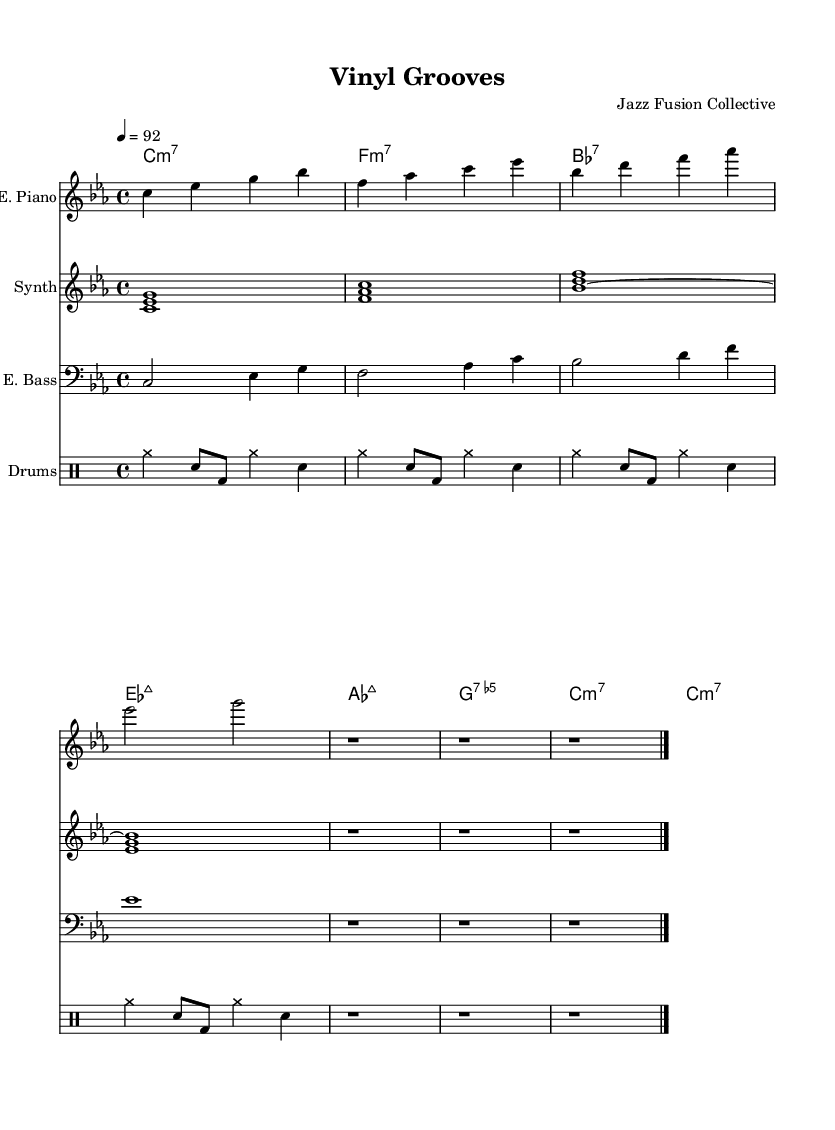What is the key signature of this music? The key signature is C minor, which is indicated by three flats. In the first measure, there are flats on B, E, and A, confirming that the piece is written in C minor.
Answer: C minor What is the time signature of this music? The time signature shown at the beginning of the score is four beats per measure, indicated by the "4/4" notation. This means that each measure contains four quarter note beats.
Answer: 4/4 What is the tempo marking of this music? The tempo marking indicates a speed of 92 beats per minute, which is shown in the notation as "4 = 92." This means that the quarter note gets a beat of 92 BPM.
Answer: 92 How many measures are there in the electric piano part? There are a total of 13 measures in the electric piano part, which is determined by counting the divisions separated by the bar lines in the provided music.
Answer: 13 Which chords are used in the piece? The chords listed in the ChordNames section include C minor 7, F minor 7, B flat major 7, E flat major 7, A flat major 7, G dominant 7.5, and a repetition of C minor 7. This shows the harmonic structure of the piece.
Answer: C minor 7, F minor 7, B flat major 7, E flat major 7, A flat major 7, G dominant 7.5 What instrument plays a prominent role in the texture of this piece? The electric piano features prominently in this piece and is responsible for the harmonic and melodic content throughout the score, distinguished by its dedicated staff.
Answer: Electric piano Does the synthesizer play a sustained sound throughout? Yes, the synthesizer plays sustained chords throughout the piece, as indicated by the tied notes (~) which show that the notes are held for the duration of the whole note.
Answer: Yes 